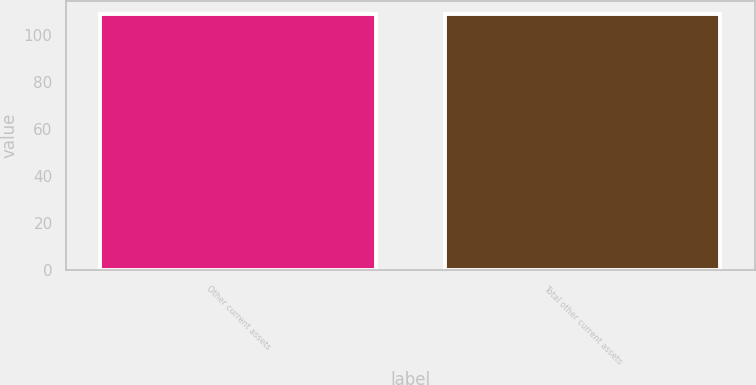Convert chart. <chart><loc_0><loc_0><loc_500><loc_500><bar_chart><fcel>Other current assets<fcel>Total other current assets<nl><fcel>109<fcel>109.1<nl></chart> 